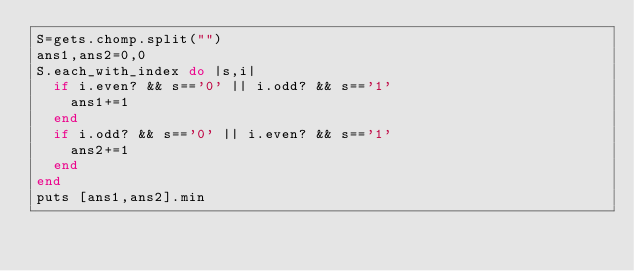<code> <loc_0><loc_0><loc_500><loc_500><_Ruby_>S=gets.chomp.split("")
ans1,ans2=0,0
S.each_with_index do |s,i|
  if i.even? && s=='0' || i.odd? && s=='1'
    ans1+=1
  end
  if i.odd? && s=='0' || i.even? && s=='1'
    ans2+=1
  end
end
puts [ans1,ans2].min</code> 